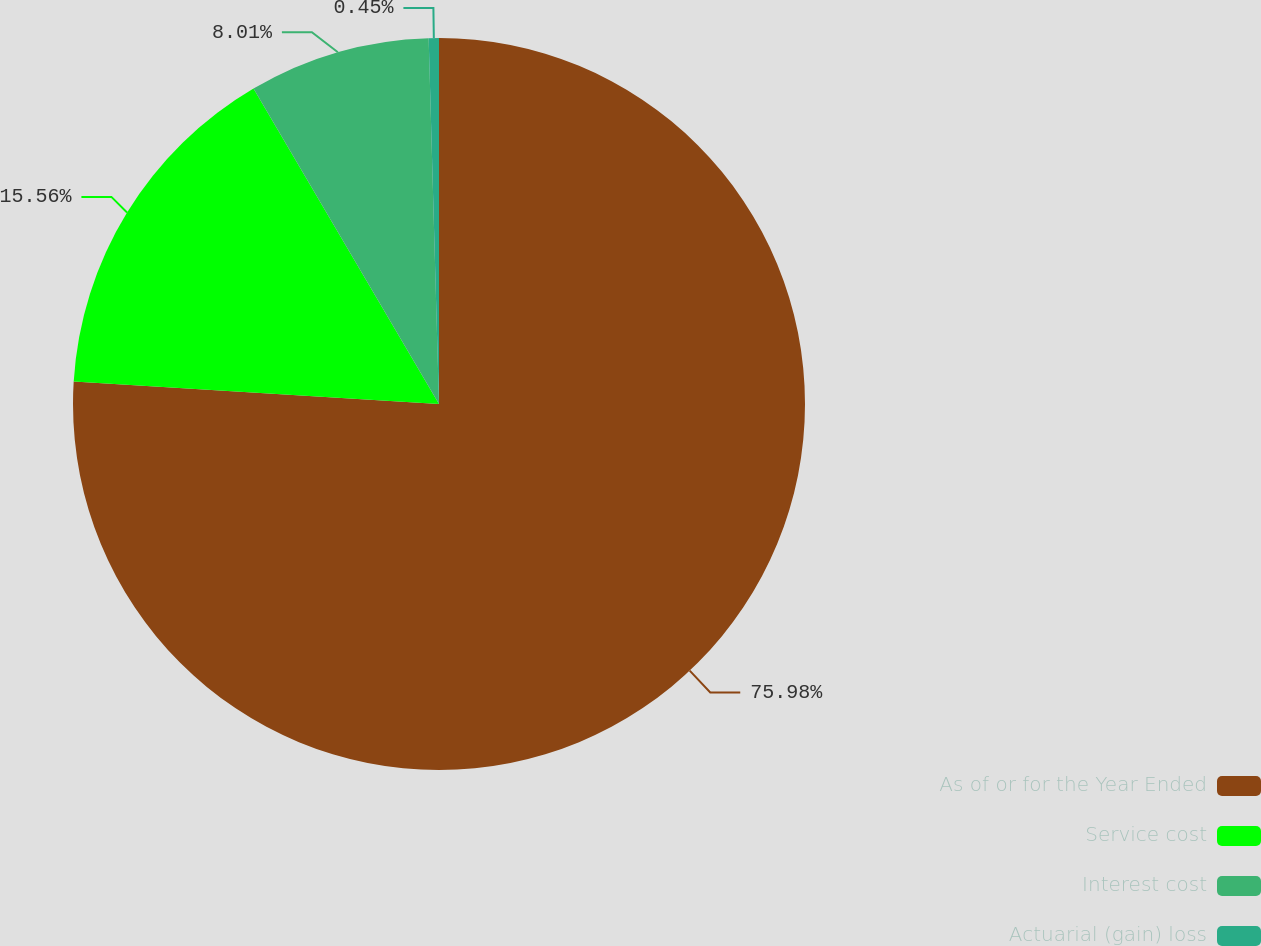Convert chart. <chart><loc_0><loc_0><loc_500><loc_500><pie_chart><fcel>As of or for the Year Ended<fcel>Service cost<fcel>Interest cost<fcel>Actuarial (gain) loss<nl><fcel>75.98%<fcel>15.56%<fcel>8.01%<fcel>0.45%<nl></chart> 